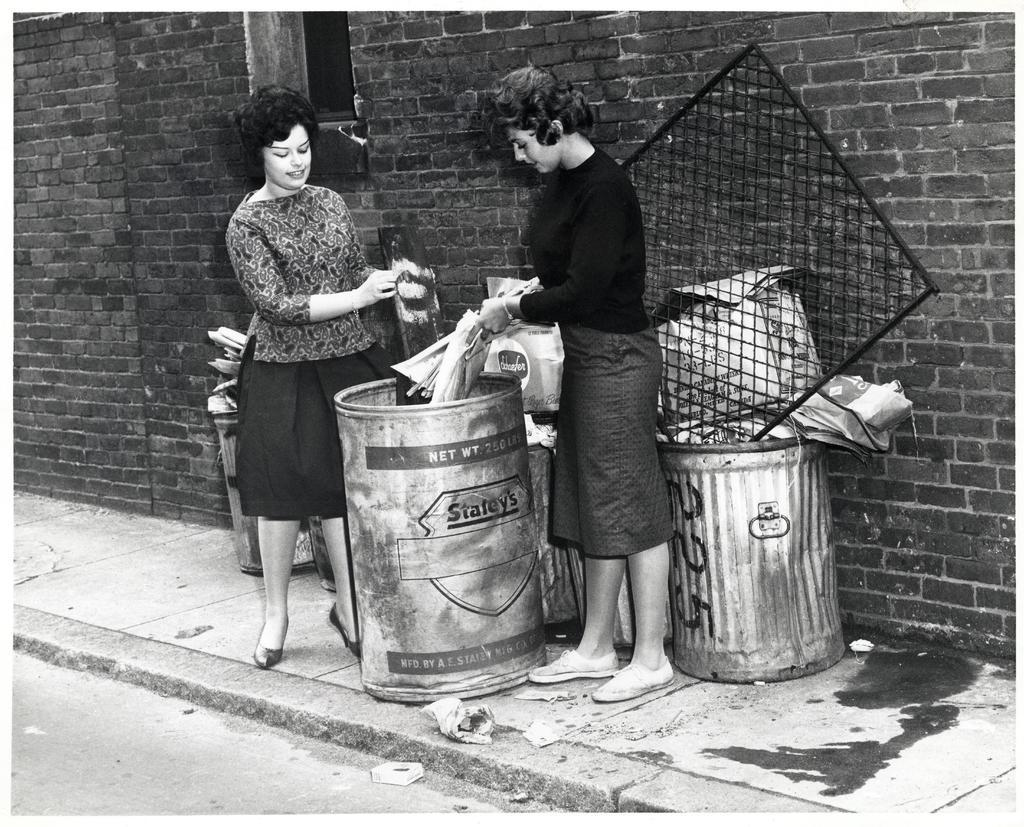Provide a one-sentence caption for the provided image. Two women throw items into a drum with a net weight of 250 pounds. 